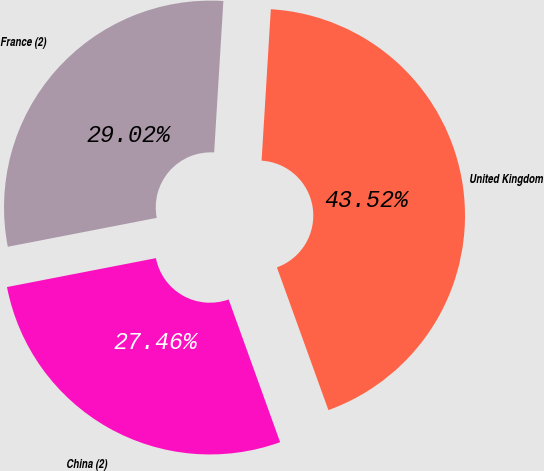<chart> <loc_0><loc_0><loc_500><loc_500><pie_chart><fcel>United Kingdom<fcel>France (2)<fcel>China (2)<nl><fcel>43.52%<fcel>29.02%<fcel>27.46%<nl></chart> 